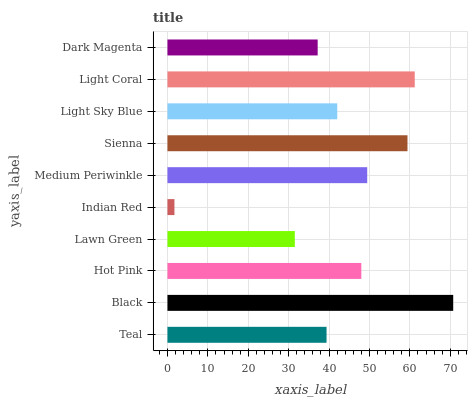Is Indian Red the minimum?
Answer yes or no. Yes. Is Black the maximum?
Answer yes or no. Yes. Is Hot Pink the minimum?
Answer yes or no. No. Is Hot Pink the maximum?
Answer yes or no. No. Is Black greater than Hot Pink?
Answer yes or no. Yes. Is Hot Pink less than Black?
Answer yes or no. Yes. Is Hot Pink greater than Black?
Answer yes or no. No. Is Black less than Hot Pink?
Answer yes or no. No. Is Hot Pink the high median?
Answer yes or no. Yes. Is Light Sky Blue the low median?
Answer yes or no. Yes. Is Light Sky Blue the high median?
Answer yes or no. No. Is Dark Magenta the low median?
Answer yes or no. No. 